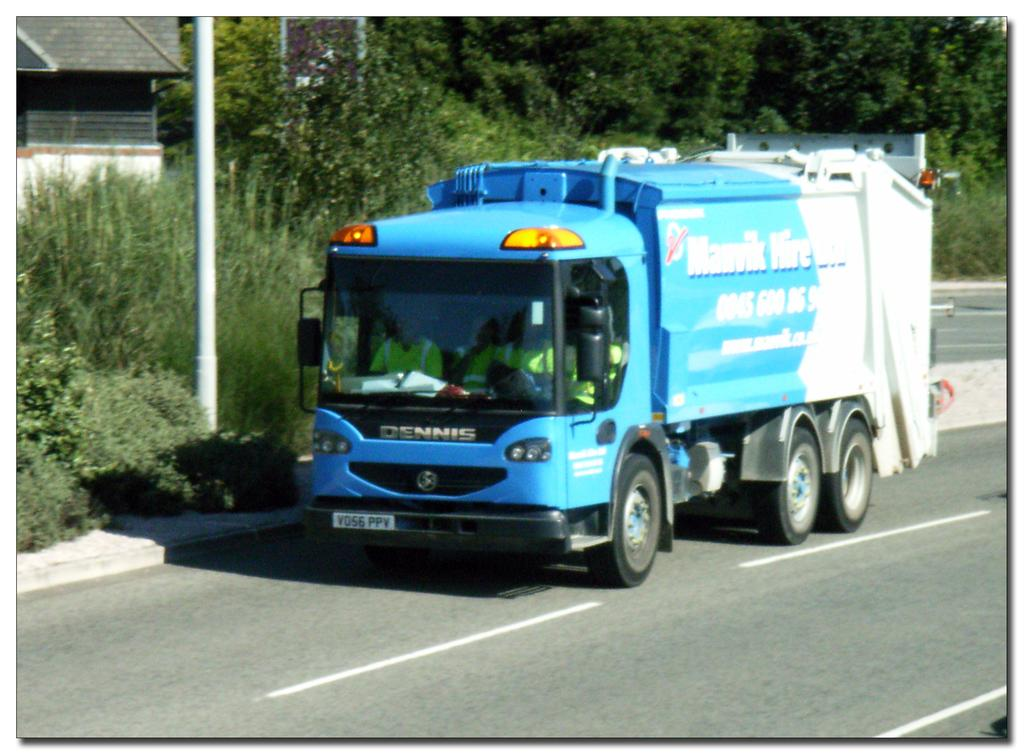What is the main subject of the image? There is a vehicle in the image. Where is the vehicle located? The vehicle is on the road. What can be seen on the left side of the image? There is a shed on the left side of the image. What is visible in the background of the image? There are trees and a pole visible in the background of the image. What degree does the duck in the image have? There is no duck present in the image, so it cannot have a degree. 